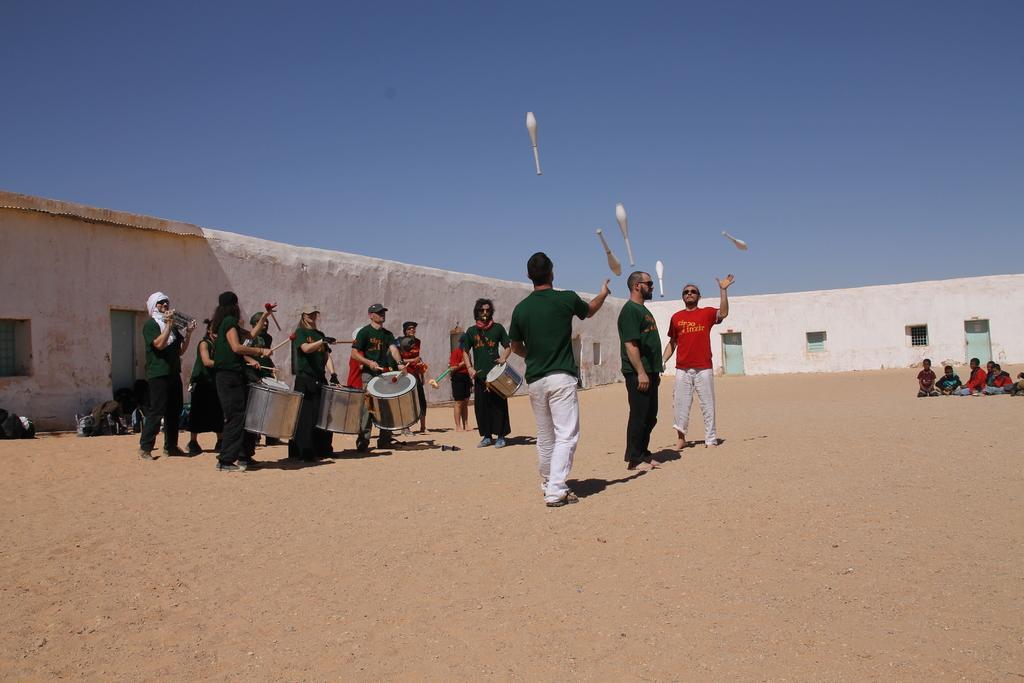How would you summarize this image in a sentence or two? In the foreground of the image we can see sand. In the middle of the image we can see some people are playing drums, some of them are playing with sticks and some of them are sitting on the sand. On the top of the image we can see the sky. 